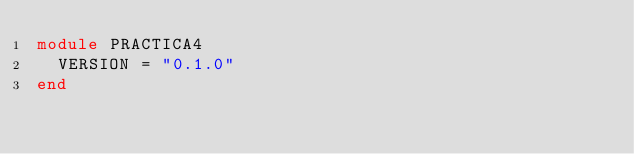Convert code to text. <code><loc_0><loc_0><loc_500><loc_500><_Ruby_>module PRACTICA4
  VERSION = "0.1.0"
end
</code> 